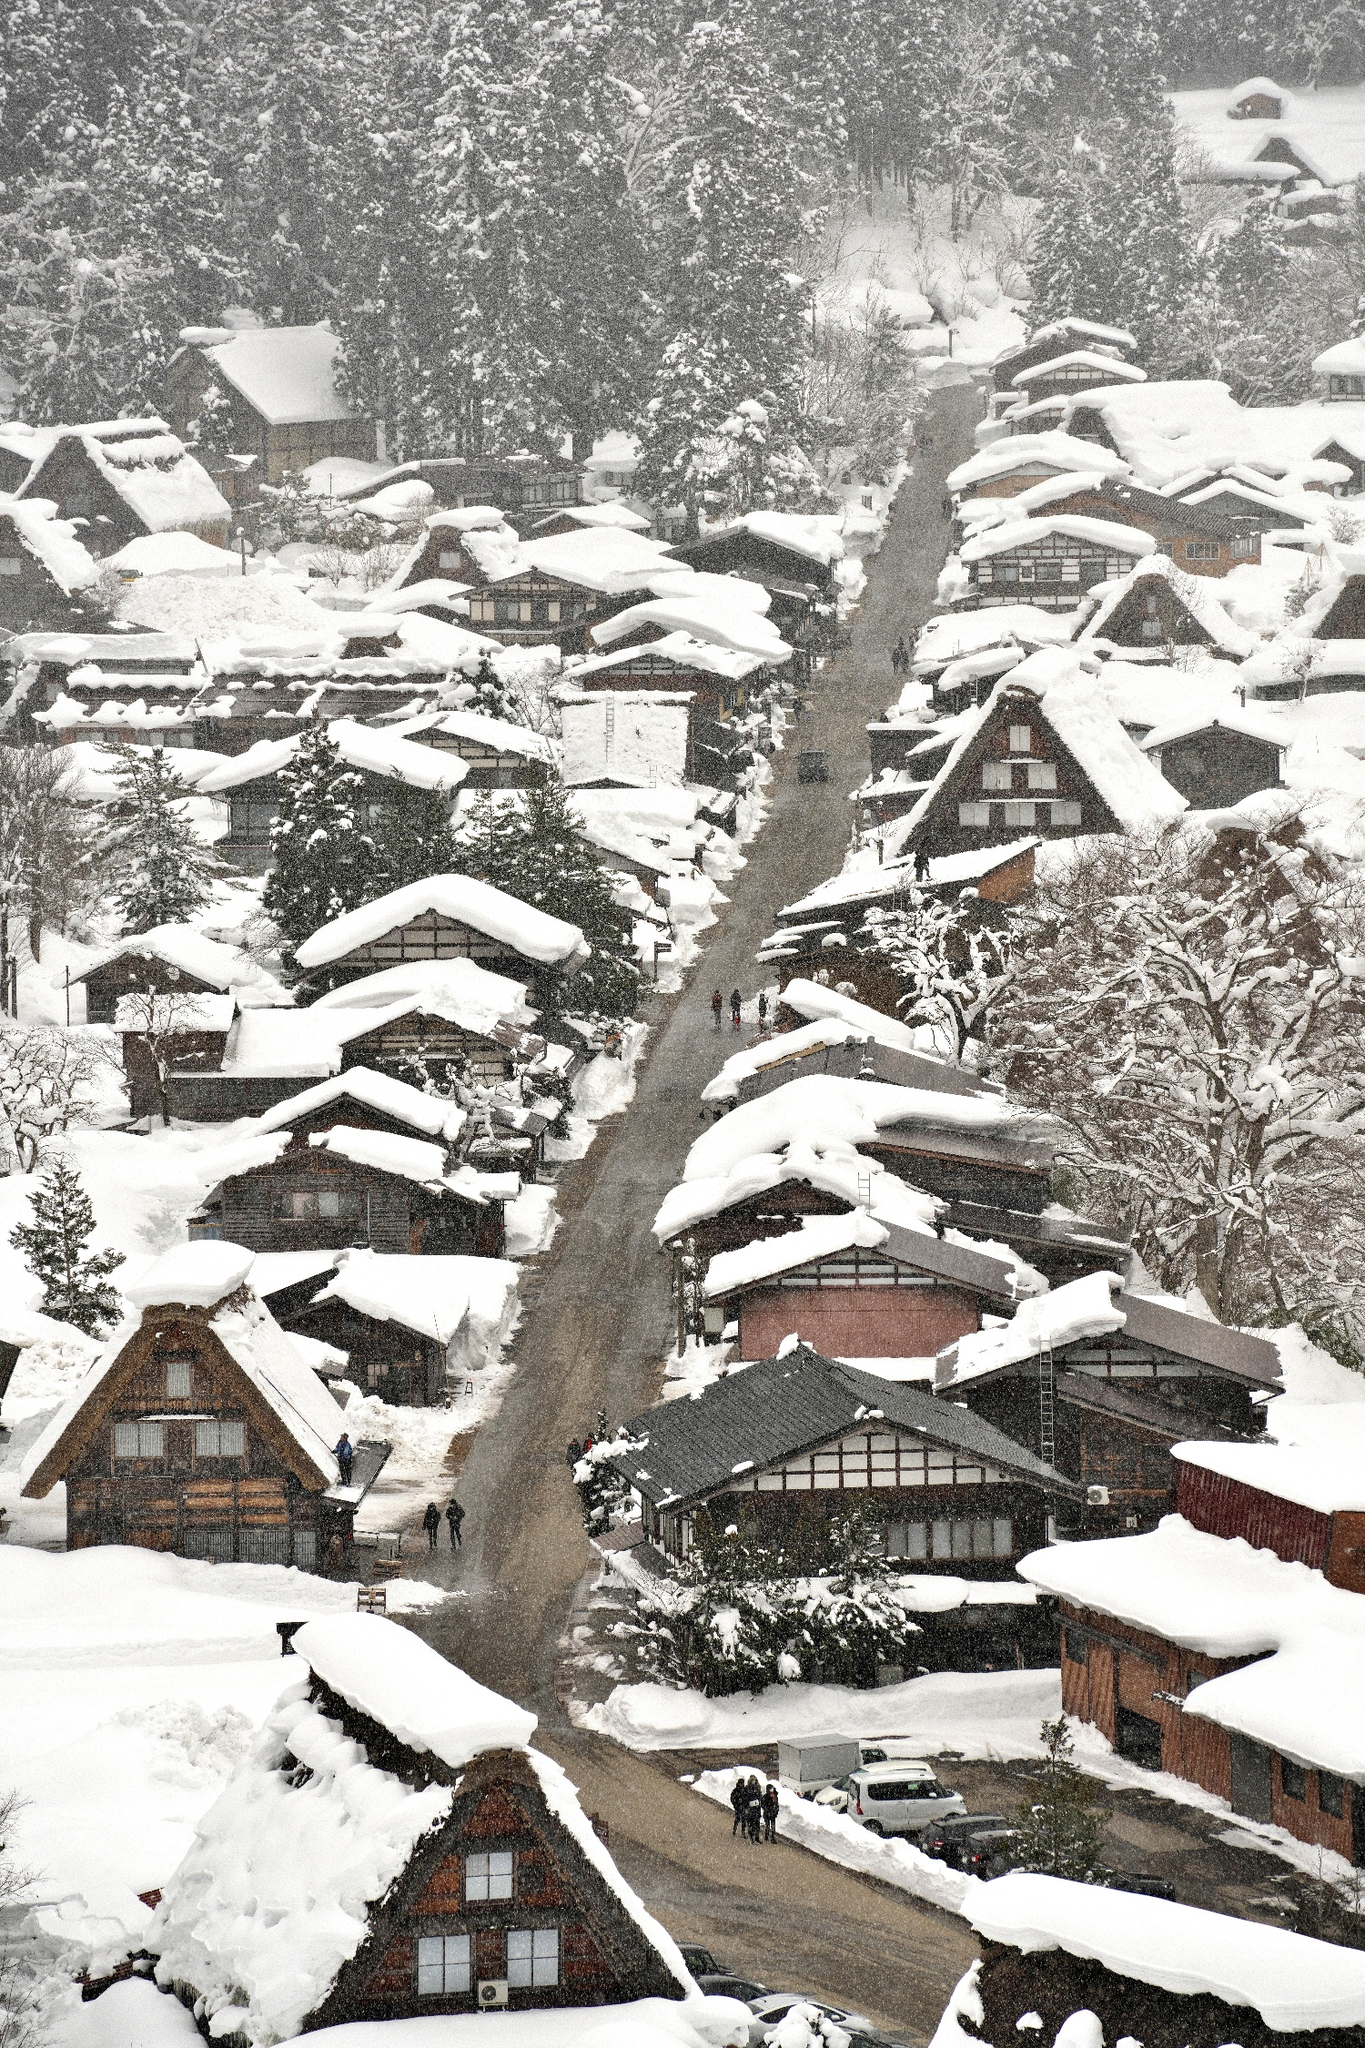What kind of climate does this area experience? The Shirakawa-go area experiences a humid continental climate, typified by distinct seasons including warm summers and cold winters. The winters are particularly harsh, evident from the thick layers of snow covering the roofs and surrounding landscape in the image. This heavy snowfall influences local lifestyles and even the architectural decisions, as seen in the steep roofs which prevent snow accumulation. 